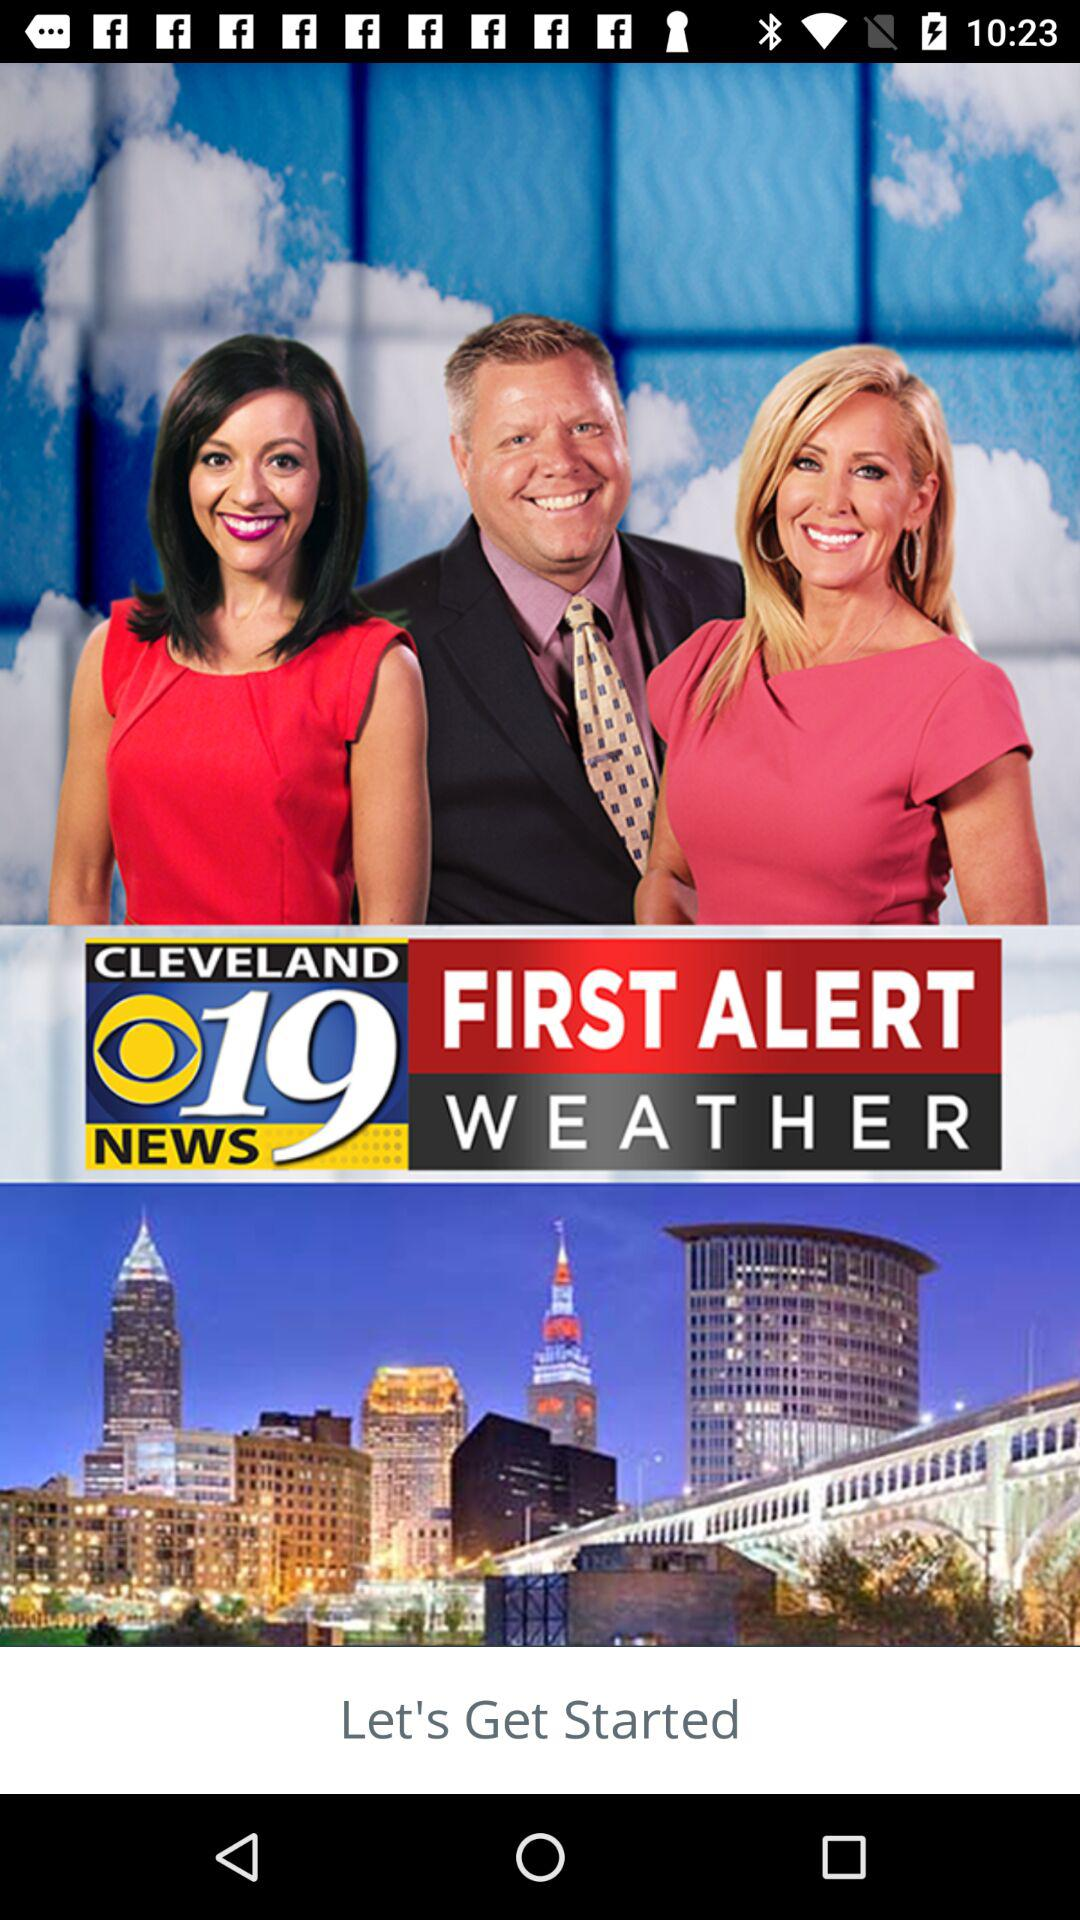What is the application name? The application name is "CLEVELAND 19 NEWS FIRST ALERT WEATHER". 